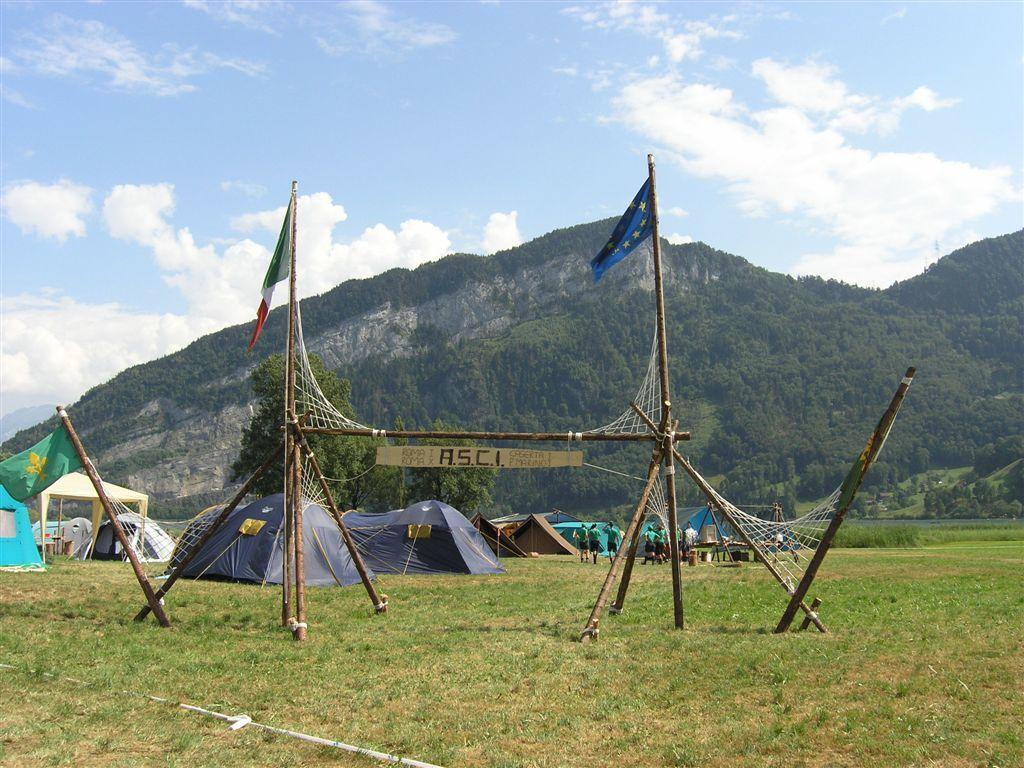What can be seen in the foreground area of the image? In the foreground area of the image, there are flags, a net, bamboos, and grassland. What is the purpose of the net in the image? The purpose of the net in the image is not explicitly stated, but it could be used for sports or other activities. What is visible in the background of the image? In the background of the image, there are tents, people, mountains, and sky. Can you see a rose growing in the grassland in the image? There is no rose visible in the grassland in the image. Is there a brake system visible on any of the people in the background of the image? There is no brake system visible on any of the people in the background of the image. 